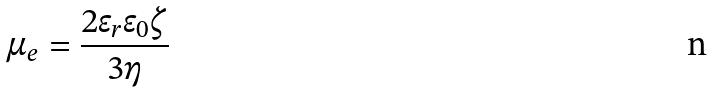Convert formula to latex. <formula><loc_0><loc_0><loc_500><loc_500>\mu _ { e } = \frac { 2 \epsilon _ { r } \epsilon _ { 0 } \zeta } { 3 \eta }</formula> 